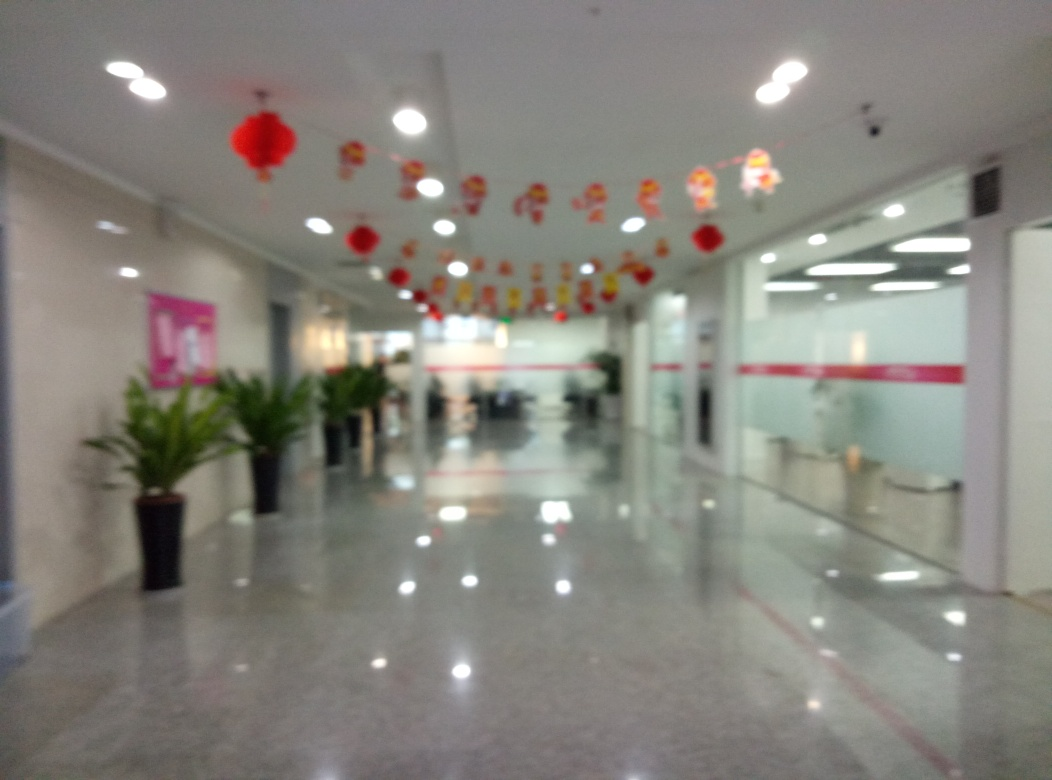What event might be taking place here given the decorations visible? The presence of red lanterns hanging from the ceiling suggests that there could be a celebration related to Chinese culture, possibly for Chinese New Year or another festival. Are there any details that give away the location or type of building this might be? The image seems to show a hallway in a modern building with reflective flooring. The glass doors, potted plants, and signage contribute to a commercial or possibly a corporate setting. Specific location details are not discernible due to the blurred nature of the photo. 